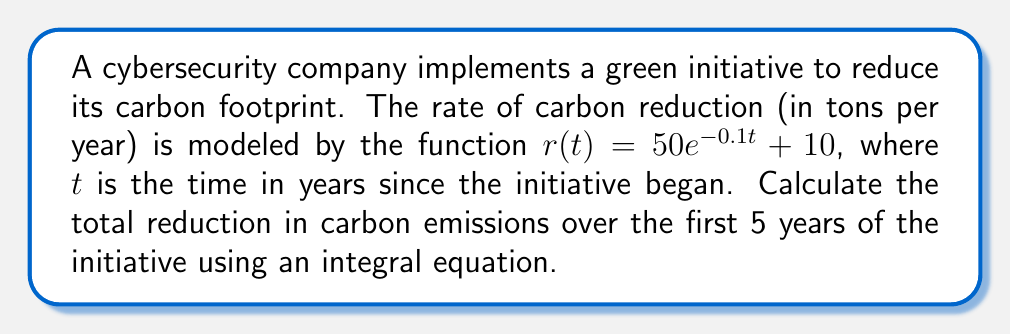Can you solve this math problem? To solve this problem, we need to follow these steps:

1) The total reduction in carbon emissions over a period of time is given by the integral of the rate function over that time period.

2) We need to integrate $r(t)$ from $t=0$ to $t=5$:

   $$\int_0^5 r(t) dt = \int_0^5 (50e^{-0.1t} + 10) dt$$

3) Let's split this into two integrals:

   $$\int_0^5 50e^{-0.1t} dt + \int_0^5 10 dt$$

4) For the first integral, we can use the substitution method:
   Let $u = -0.1t$, then $du = -0.1dt$ or $dt = -10du$

   $$-500 \int_0^{-0.5} e^u du = -500 [e^u]_0^{-0.5} = -500(e^{-0.5} - 1)$$

5) The second integral is straightforward:

   $$10 \int_0^5 dt = 10t |_0^5 = 50$$

6) Adding the results from steps 4 and 5:

   $$-500(e^{-0.5} - 1) + 50 = -500e^{-0.5} + 500 + 50 = 550 - 500e^{-0.5}$$

7) Calculate the final value:

   $$550 - 500 * 0.6065 = 246.75$$

Thus, the total reduction in carbon emissions over the first 5 years is approximately 246.75 tons.
Answer: 246.75 tons 